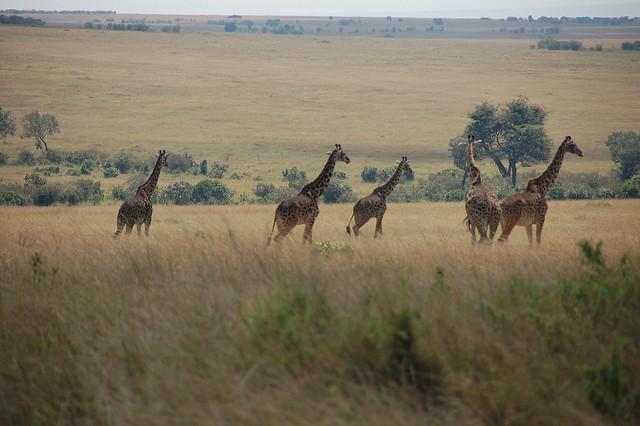How many giraffes are in the picture?
Give a very brief answer. 5. How many giraffes are there?
Give a very brief answer. 2. 